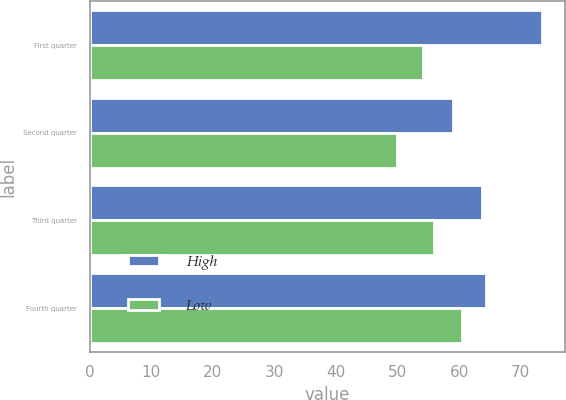Convert chart. <chart><loc_0><loc_0><loc_500><loc_500><stacked_bar_chart><ecel><fcel>First quarter<fcel>Second quarter<fcel>Third quarter<fcel>Fourth quarter<nl><fcel>High<fcel>73.46<fcel>58.94<fcel>63.73<fcel>64.4<nl><fcel>Low<fcel>54.18<fcel>49.91<fcel>56<fcel>60.43<nl></chart> 